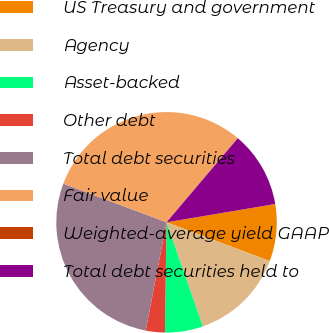<chart> <loc_0><loc_0><loc_500><loc_500><pie_chart><fcel>US Treasury and government<fcel>Agency<fcel>Asset-backed<fcel>Other debt<fcel>Total debt securities<fcel>Fair value<fcel>Weighted-average yield GAAP<fcel>Total debt securities held to<nl><fcel>8.37%<fcel>13.94%<fcel>5.58%<fcel>2.79%<fcel>27.69%<fcel>30.48%<fcel>0.0%<fcel>11.16%<nl></chart> 